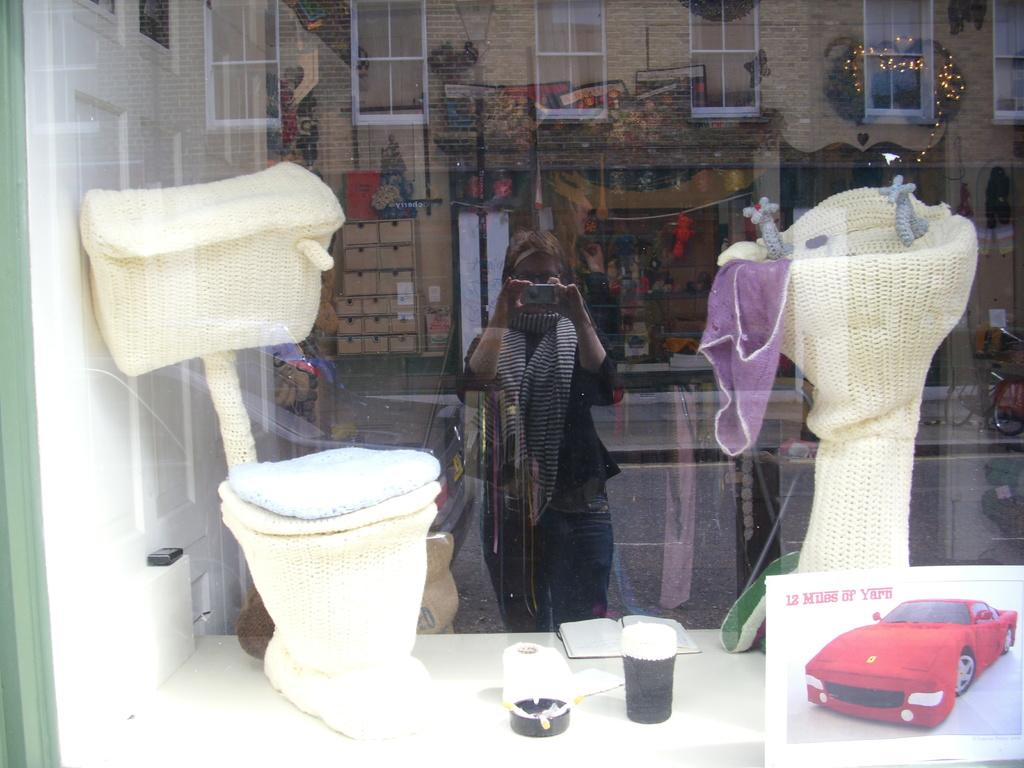What type of fixture is present in the image for washing hands? There is a wash basin in the image for washing hands. What other fixture is present in the image for personal hygiene? There is a commode in the image for personal hygiene. What can be seen in the reflection of the glass in the image? The reflection of the glass shows buildings. Who is responsible for capturing the image? A woman is holding the camera in the image. What type of faucet is installed on the wash basin in the image? The provided facts do not mention any specific type of faucet on the wash basin in the image. What time of day is it in the image? The provided facts do not mention any specific time of day in the image. 